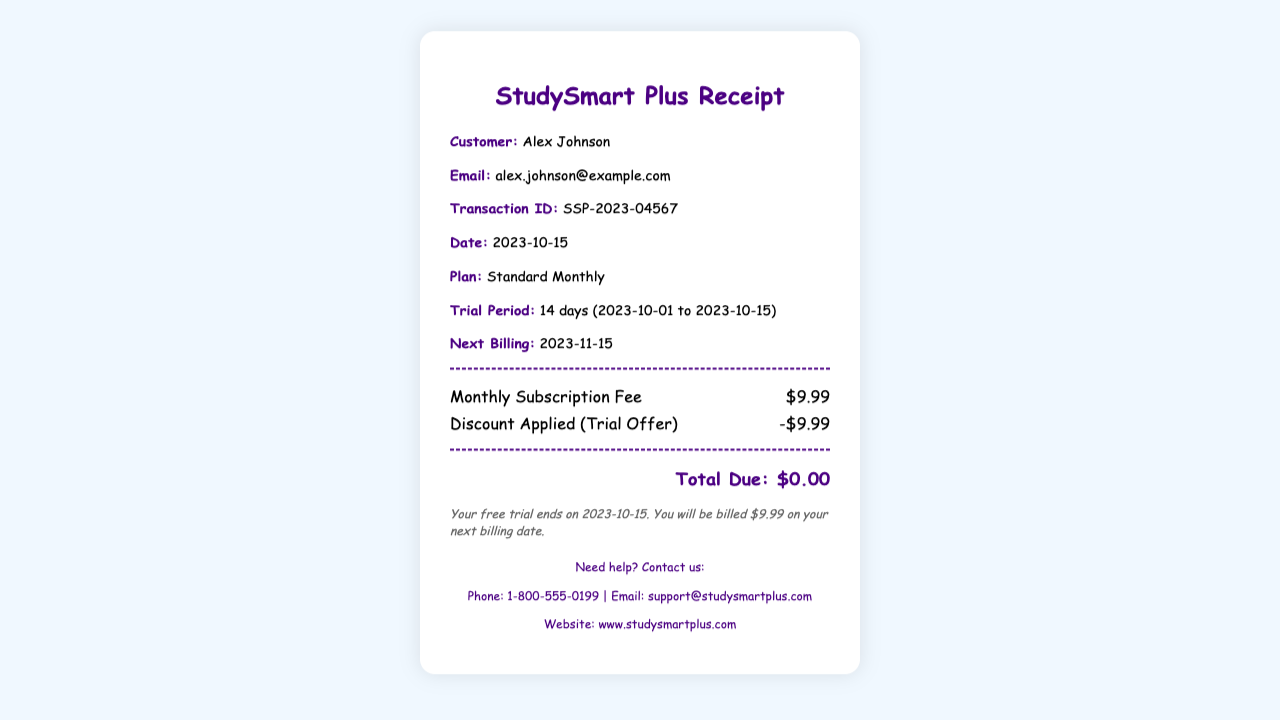What is the customer's name? The customer's name is listed at the beginning of the receipt.
Answer: Alex Johnson What is the email address provided? The email address can be found in the info section of the receipt.
Answer: alex.johnson@example.com What is the transaction ID? The transaction ID is specified on the receipt for reference.
Answer: SSP-2023-04567 What is the plan type? The type of plan is mentioned in the details section of the document.
Answer: Standard Monthly What is the duration of the trial period? The trial period duration is stated clearly in the document along with the dates.
Answer: 14 days (2023-10-01 to 2023-10-15) When is the next billing date? The next billing date is provided as part of the subscription details.
Answer: 2023-11-15 What was the monthly subscription fee? The fee is mentioned among the charges listed in the document.
Answer: $9.99 What total amount is due? The total due amount is calculated and displayed at the bottom of the receipt.
Answer: $0.00 What discount was applied? The discount applied during the trial offer is noted in the charges section.
Answer: -$9.99 